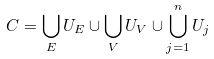Convert formula to latex. <formula><loc_0><loc_0><loc_500><loc_500>C = \bigcup _ { E } U _ { E } \cup \bigcup _ { V } U _ { V } \cup \bigcup _ { j = 1 } ^ { n } U _ { j }</formula> 